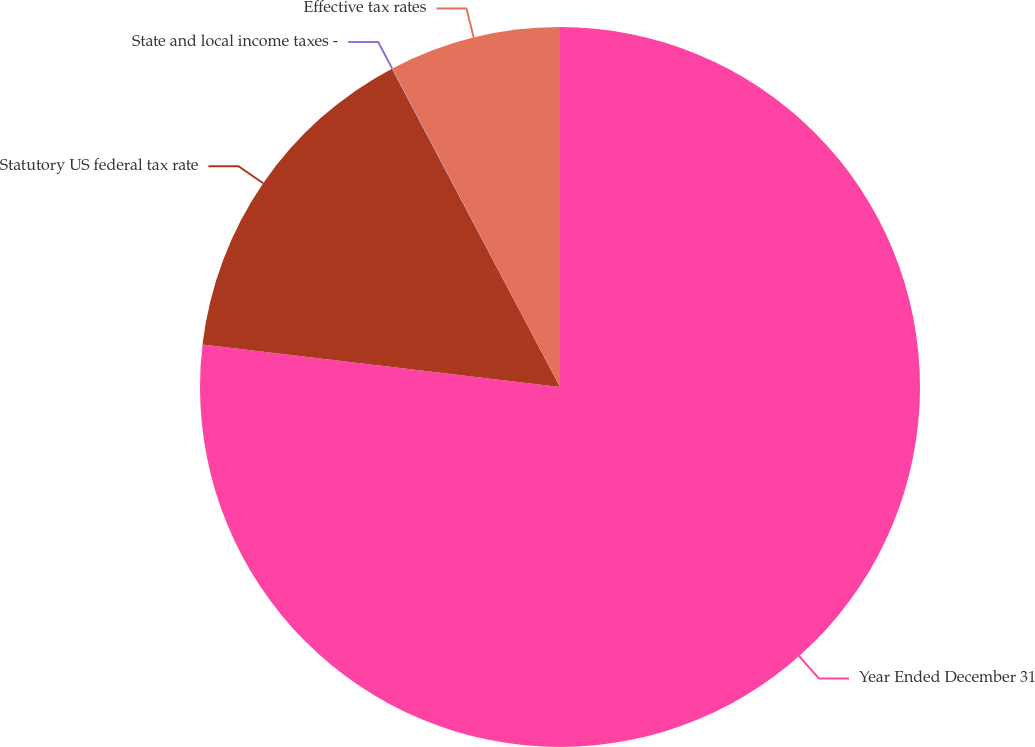Convert chart to OTSL. <chart><loc_0><loc_0><loc_500><loc_500><pie_chart><fcel>Year Ended December 31<fcel>Statutory US federal tax rate<fcel>State and local income taxes -<fcel>Effective tax rates<nl><fcel>76.88%<fcel>15.39%<fcel>0.02%<fcel>7.71%<nl></chart> 